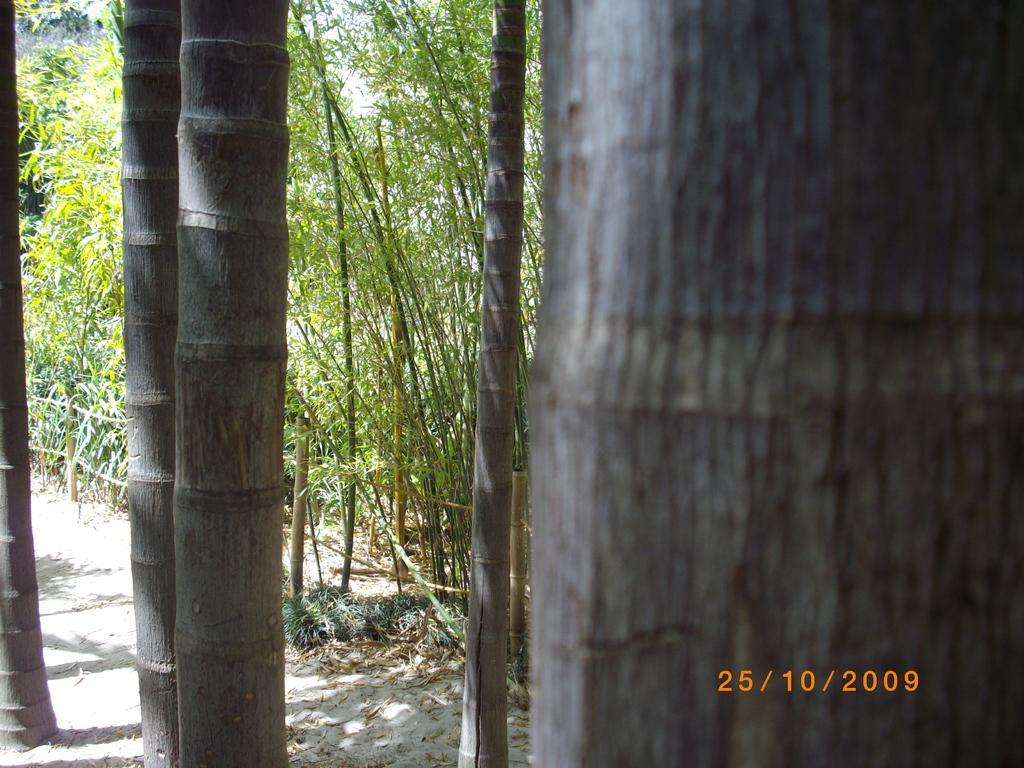What type of vegetation is present in the image? The image contains trees and plants. What is the texture of the ground in the image? There is sand on the ground in the image. How much attention is the honey receiving in the image? There is no honey present in the image, so it cannot receive any attention. 